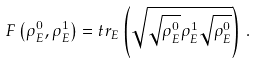Convert formula to latex. <formula><loc_0><loc_0><loc_500><loc_500>F \left ( \rho _ { E } ^ { 0 } , \rho _ { E } ^ { 1 } \right ) = t r _ { E } \left ( \sqrt { \sqrt { \rho _ { E } ^ { 0 } } \rho _ { E } ^ { 1 } \sqrt { \rho _ { E } ^ { 0 } } } \right ) \, .</formula> 